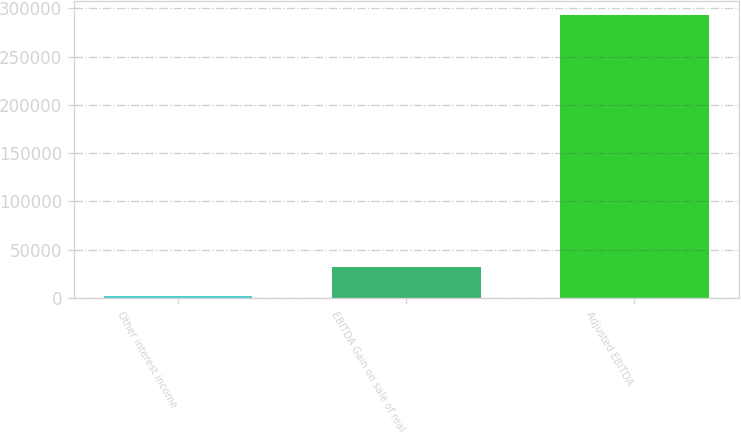Convert chart to OTSL. <chart><loc_0><loc_0><loc_500><loc_500><bar_chart><fcel>Other interest income<fcel>EBITDA Gain on sale of real<fcel>Adjusted EBITDA<nl><fcel>2616<fcel>31637.1<fcel>292827<nl></chart> 